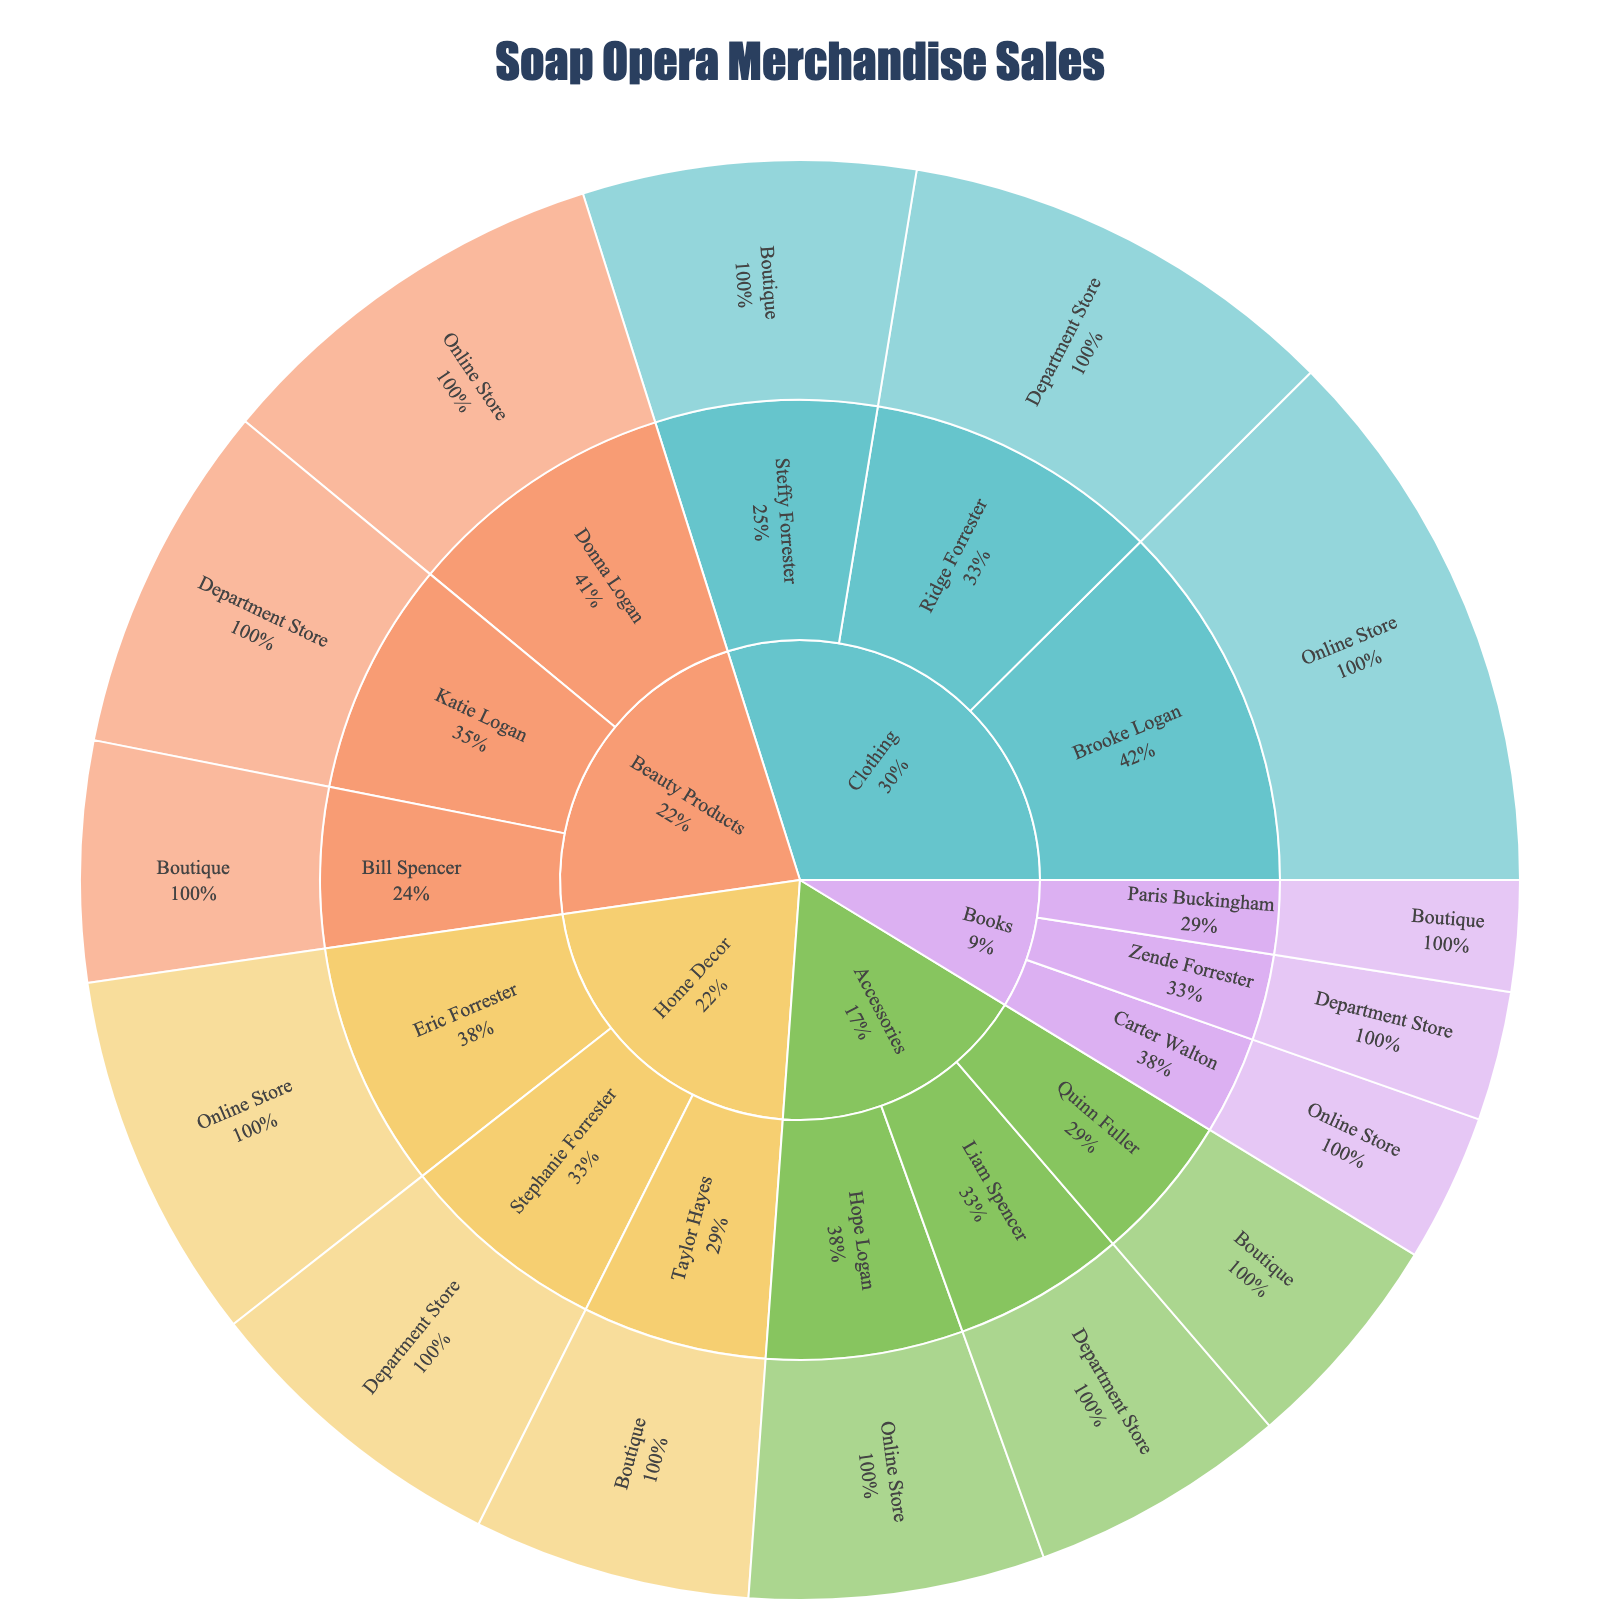What is the total sales amount for 'Clothing' products? Sum up all sales values under 'Clothing', which are 150,000, 120,000, and 90,000. Therefore, the total sales amount is 360,000.
Answer: 360,000 Which character associated with 'Beauty Products' has the highest sales? In the 'Beauty Products' category, the sales are 110,000 (Donna Logan), 95,000 (Katie Logan), and 65,000 (Bill Spencer). Donna Logan has the highest sales among them.
Answer: Donna Logan What is the sales difference between 'Books' and 'Home Decor' products sold at the Online Store? 'Books' sales at the Online Store are 40,000, and 'Home Decor' sales at the Online Store are 100,000. The difference is 100,000 - 40,000 = 60,000.
Answer: 60,000 Which product type has the highest total sales? To find the product type with the highest total sales, sum the sales for each category: Clothing (360,000), Accessories (210,000), Home Decor (260,000), Beauty Products (270,000), and Books (105,000). Beauty Products have the highest total sales with 270,000.
Answer: Clothing How much more does Ridge Forrester's sales at Department Stores compare to Steffy Forrester's sales at Boutiques? Ridge Forrester's sales at Department Stores are 120,000, while Steffy Forrester's sales at Boutiques are 90,000. The difference is 120,000 - 90,000 = 30,000.
Answer: 30,000 Which character associated with 'Accessories' has the lowest sales, and what is the amount? Within the 'Accessories' category, the sales are 80,000 (Hope Logan), 70,000 (Liam Spencer), and 60,000 (Quinn Fuller). Quinn Fuller has the lowest sales amounting to 60,000.
Answer: Quinn Fuller, 60,000 What proportion of 'Clothing' sales does Brooke Logan contribute to? Brooke Logan's sales are 150,000 out of the total Clothing sales of 360,000. The proportion is 150,000 / 360,000 = 0.4167, which is approximately 41.67%.
Answer: 41.67% What is the total sales amount for items purchased at Department Stores only? Sum the sales values at Department Stores, which are 120,000 (Clothing), 70,000 (Accessories), 85,000 (Home Decor), 95,000 (Beauty Products), and 35,000 (Books). The total is 405,000.
Answer: 405,000 In which purchase location does 'Beauty Products' have the second highest sales? For 'Beauty Products', the sales are 110,000 (Online Store), 95,000 (Department Store), and 65,000 (Boutique). The second highest sales occur at the Department Store, which is 95,000.
Answer: Department Store How do the total sales of 'Books' across all purchase locations compare to 'Accessories'? 'Books' total sales are 40,000 (Online Store), 35,000 (Department Store), and 30,000 (Boutique) summing up to 105,000. 'Accessories' total sales are 80,000 (Online Store), 70,000 (Department Store), and 60,000 (Boutique) summing up to 210,000. Accessories have higher total sales by 210,000 - 105,000 = 105,000.
Answer: Accessories, 105,000 